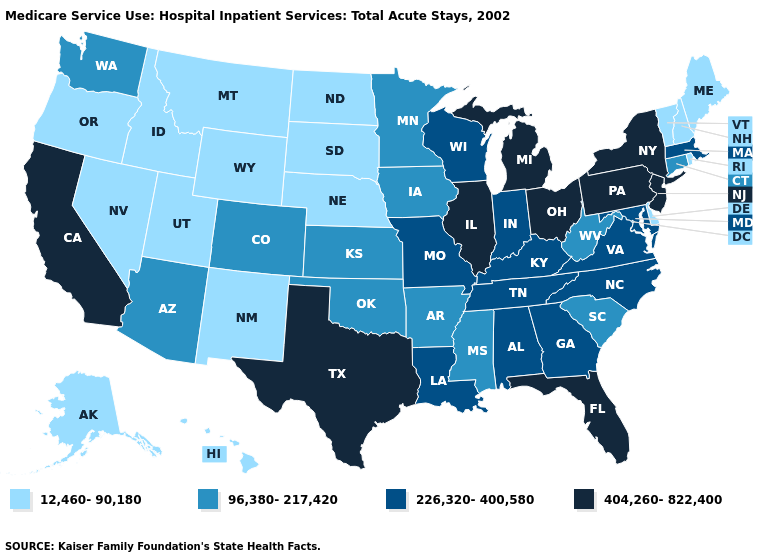What is the value of Wisconsin?
Short answer required. 226,320-400,580. Does Montana have a higher value than Illinois?
Write a very short answer. No. What is the value of Iowa?
Write a very short answer. 96,380-217,420. Name the states that have a value in the range 404,260-822,400?
Give a very brief answer. California, Florida, Illinois, Michigan, New Jersey, New York, Ohio, Pennsylvania, Texas. Name the states that have a value in the range 96,380-217,420?
Short answer required. Arizona, Arkansas, Colorado, Connecticut, Iowa, Kansas, Minnesota, Mississippi, Oklahoma, South Carolina, Washington, West Virginia. Does Louisiana have the highest value in the USA?
Quick response, please. No. Name the states that have a value in the range 12,460-90,180?
Concise answer only. Alaska, Delaware, Hawaii, Idaho, Maine, Montana, Nebraska, Nevada, New Hampshire, New Mexico, North Dakota, Oregon, Rhode Island, South Dakota, Utah, Vermont, Wyoming. What is the value of New Mexico?
Short answer required. 12,460-90,180. Does Nebraska have the lowest value in the MidWest?
Short answer required. Yes. Name the states that have a value in the range 12,460-90,180?
Give a very brief answer. Alaska, Delaware, Hawaii, Idaho, Maine, Montana, Nebraska, Nevada, New Hampshire, New Mexico, North Dakota, Oregon, Rhode Island, South Dakota, Utah, Vermont, Wyoming. What is the value of Nevada?
Short answer required. 12,460-90,180. What is the value of New Hampshire?
Give a very brief answer. 12,460-90,180. Does Colorado have a higher value than Nebraska?
Short answer required. Yes. What is the highest value in states that border Oregon?
Write a very short answer. 404,260-822,400. What is the value of Arkansas?
Quick response, please. 96,380-217,420. 